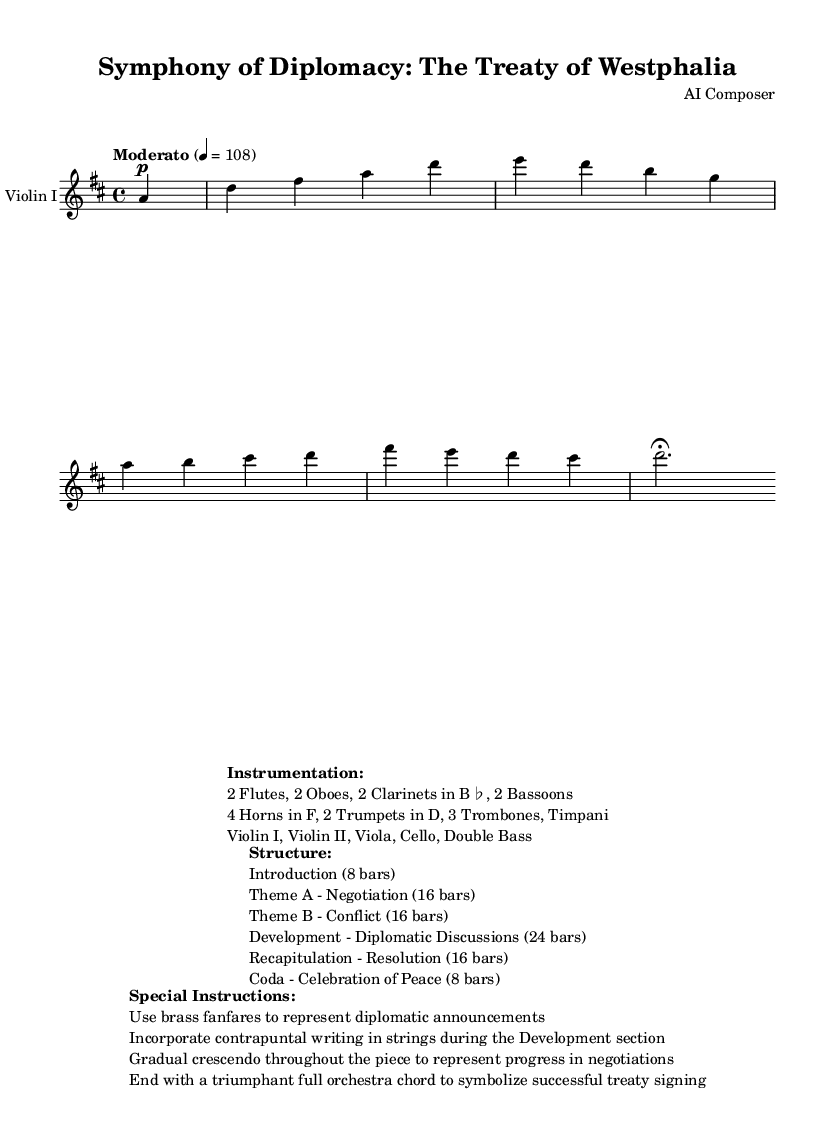What is the key signature of this music? The key signature is D major, which has two sharps (F♯ and C♯).
Answer: D major What is the time signature of the piece? The time signature is 4/4, indicating four beats per measure.
Answer: 4/4 What tempo marking is used for the symphony? The tempo marking is "Moderato," which typically indicates a moderate pace.
Answer: Moderato How many instruments are specified in the instrumentation? The instrumentation lists a total of 15 instruments. This includes various woodwinds, brass, percussion, and string instruments.
Answer: 15 What is the function of the brass fanfares in the music? The brass fanfares represent diplomatic announcements throughout the symphony.
Answer: Diplomatic announcements What is the overall structure of the piece? The structure consists of an Introduction, two themes (A and B), a Development section, a Recapitulation, and a Coda, which reflects a typical symphonic form.
Answer: Introduction, Theme A, Theme B, Development, Recapitulation, Coda What does the crescendo throughout the piece symbolize? The gradual crescendo symbolizes progress in negotiations, suggesting a rising tension leading to resolution.
Answer: Progress in negotiations 